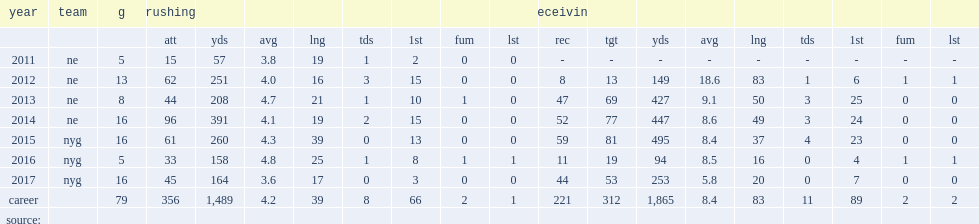How many receptions did shane vereen finish the 2013 season with? 47.0. 